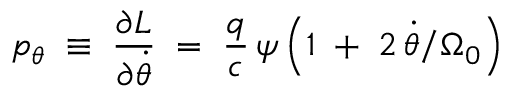<formula> <loc_0><loc_0><loc_500><loc_500>p _ { \theta } \, \equiv \, \frac { \partial L } { \partial \dot { \theta } } \, = \, \frac { q } { c } \, \psi \left ( 1 \, + \, 2 \, \dot { \theta } / \Omega _ { 0 } \right )</formula> 